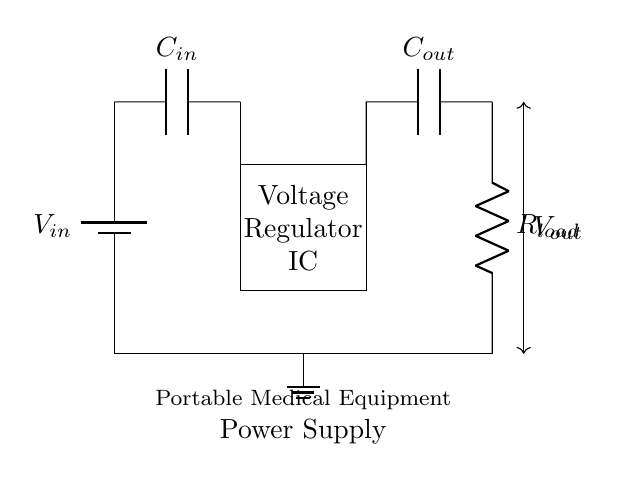What is the type of circuit shown? The circuit is a voltage regulator circuit, designed to regulate the output voltage for portable medical equipment. This is evident from the presence of the voltage regulator IC in the diagram.
Answer: Voltage regulator What components are present in the circuit? The components include an input voltage source, a voltage regulator IC, an input capacitor, an output capacitor, and a load resistor. These components are necessary for the circuit to function as a voltage regulator.
Answer: Battery, Voltage Regulator IC, Input Capacitor, Output Capacitor, Load Resistor What is the purpose of the input capacitor? The input capacitor stabilizes the input voltage and filters out any noise that may be present in the power supply. It provides a smoother voltage feed to the voltage regulator IC, thereby ensuring stable operation.
Answer: To stabilize input voltage What does Vout represent in the circuit? Vout represents the regulated output voltage provided to the load. It is taken from the output of the voltage regulator circuit, ensuring that the load receives a stable voltage regardless of variations in the input voltage.
Answer: Regulated output voltage How is the ground connected in this circuit? The ground is connected at the bottom of the circuit, serving as a reference point for all voltage levels presented. It is represented by the ground symbol in the diagram, indicating that the circuit returns current to this reference point.
Answer: Through ground connection What is the function of the load resistor? The load resistor represents the device or equipment that consumes the regulated output voltage. Its value determines the amount of current drawn from the voltage regulator, which in turn affects the performance of the circuit.
Answer: To represent load consumption 